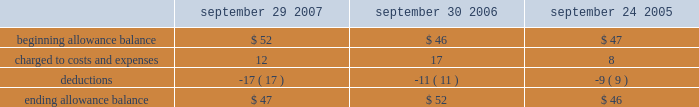Notes to consolidated financial statements ( continued ) note 2 2014financial instruments ( continued ) covered by collateral , third-party flooring arrangements , or credit insurance are outstanding with the company 2019s distribution and retail channel partners .
One customer accounted for approximately 11% ( 11 % ) of trade receivables as of september 29 , 2007 , while no customers accounted for more than 10% ( 10 % ) of trade receivables as of september 30 , 2006 .
The table summarizes the activity in the allowance for doubtful accounts ( in millions ) : september 29 , september 30 , september 24 , 2007 2006 2005 .
Vendor non-trade receivables the company has non-trade receivables from certain of its manufacturing vendors resulting from the sale of raw material components to these manufacturing vendors who manufacture sub-assemblies or assemble final products for the company .
The company purchases these raw material components directly from suppliers .
These non-trade receivables , which are included in the consolidated balance sheets in other current assets , totaled $ 2.4 billion and $ 1.6 billion as of september 29 , 2007 and september 30 , 2006 , respectively .
The company does not reflect the sale of these components in net sales and does not recognize any profits on these sales until the products are sold through to the end customer at which time the profit is recognized as a reduction of cost of sales .
Derivative financial instruments the company uses derivatives to partially offset its business exposure to foreign exchange risk .
Foreign currency forward and option contracts are used to offset the foreign exchange risk on certain existing assets and liabilities and to hedge the foreign exchange risk on expected future cash flows on certain forecasted revenue and cost of sales .
The company 2019s accounting policies for these instruments are based on whether the instruments are designated as hedge or non-hedge instruments .
The company records all derivatives on the balance sheet at fair value. .
What was the percentage change in the allowance for doubtful accounts from 2006 to 2007? 
Computations: ((47 - 52) / 52)
Answer: -0.09615. 